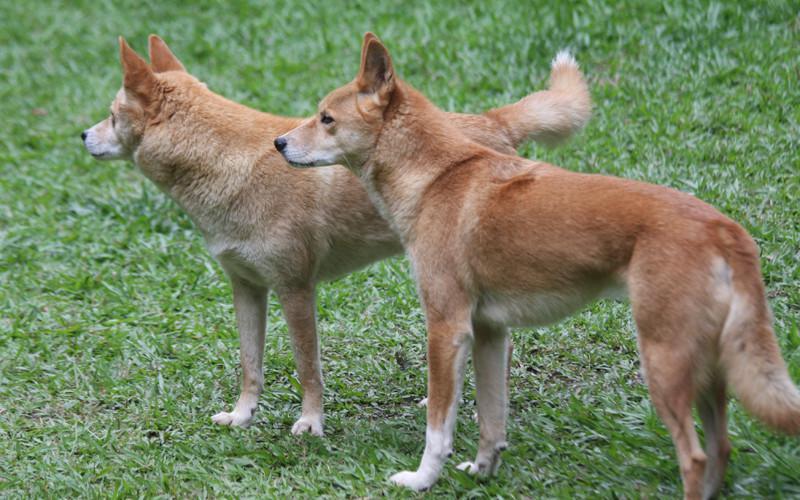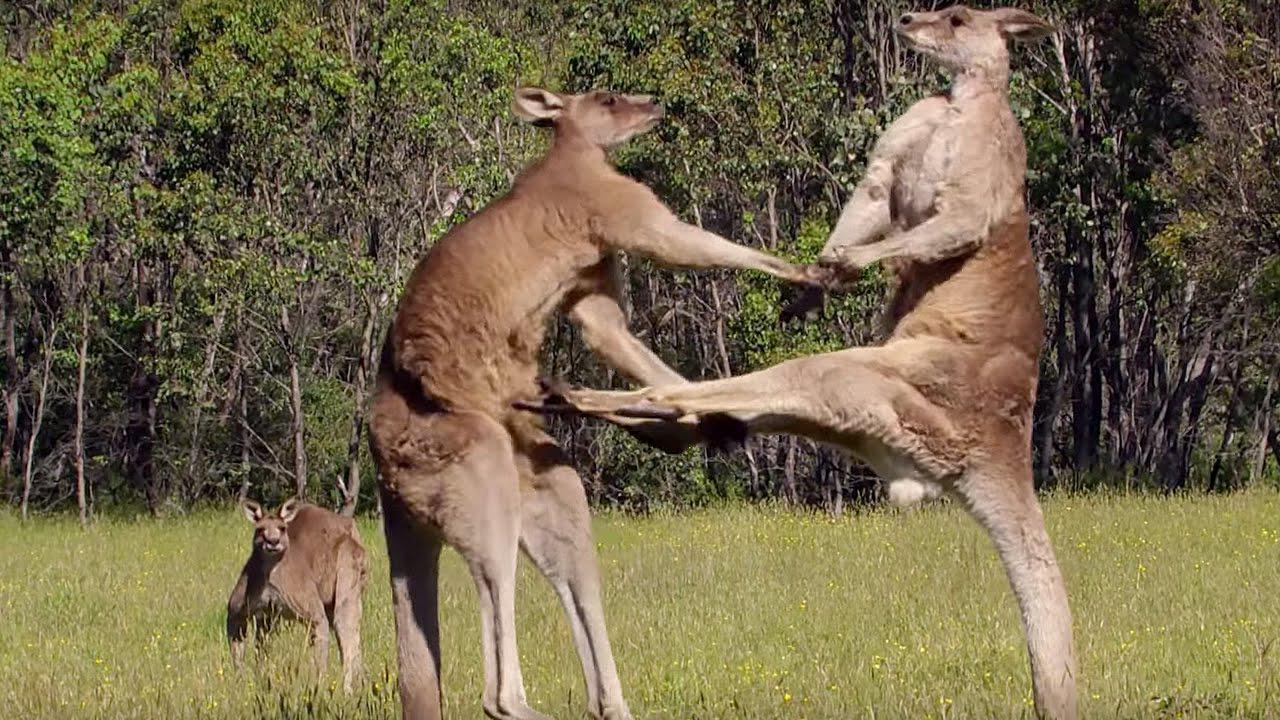The first image is the image on the left, the second image is the image on the right. For the images displayed, is the sentence "There are exactly three canines in the right image." factually correct? Answer yes or no. No. The first image is the image on the left, the second image is the image on the right. For the images shown, is this caption "The left image contains exactly two canines." true? Answer yes or no. Yes. 